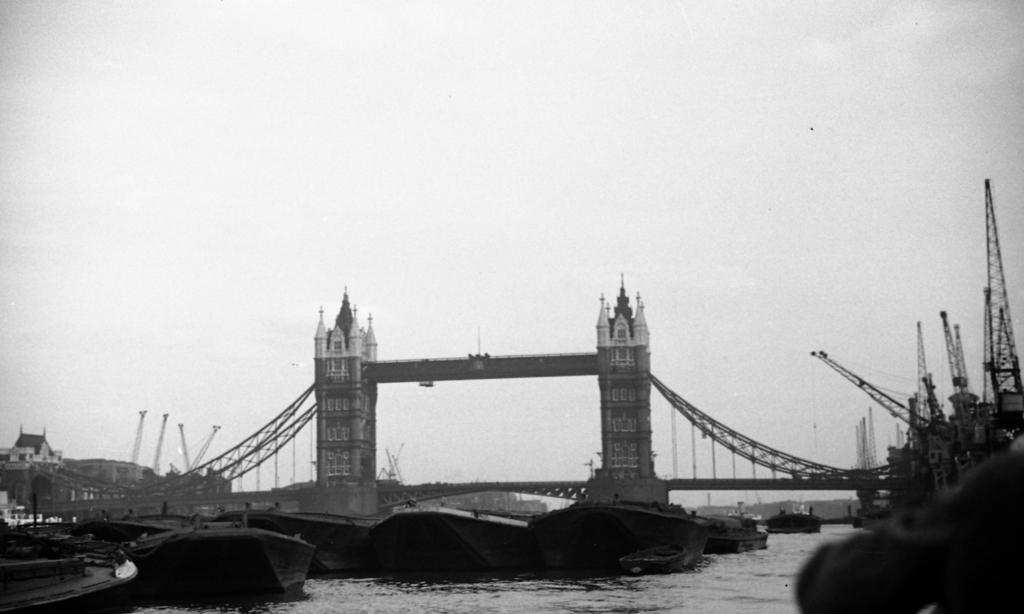What structure can be seen in the image? There is a bridge in the image. What is the bridge positioned over? The bridge is over a river. What can be seen on the water in the image? There is a fleet on the water. What type of machinery is present on the right side of the image? There are mobile cranes on the right side of the image. What is visible in the background of the image? The sky is visible in the background of the image. What type of jeans is the drum wearing in the image? There is no drum or jeans present in the image. Is there a jail visible in the image? No, there is no jail present in the image. 